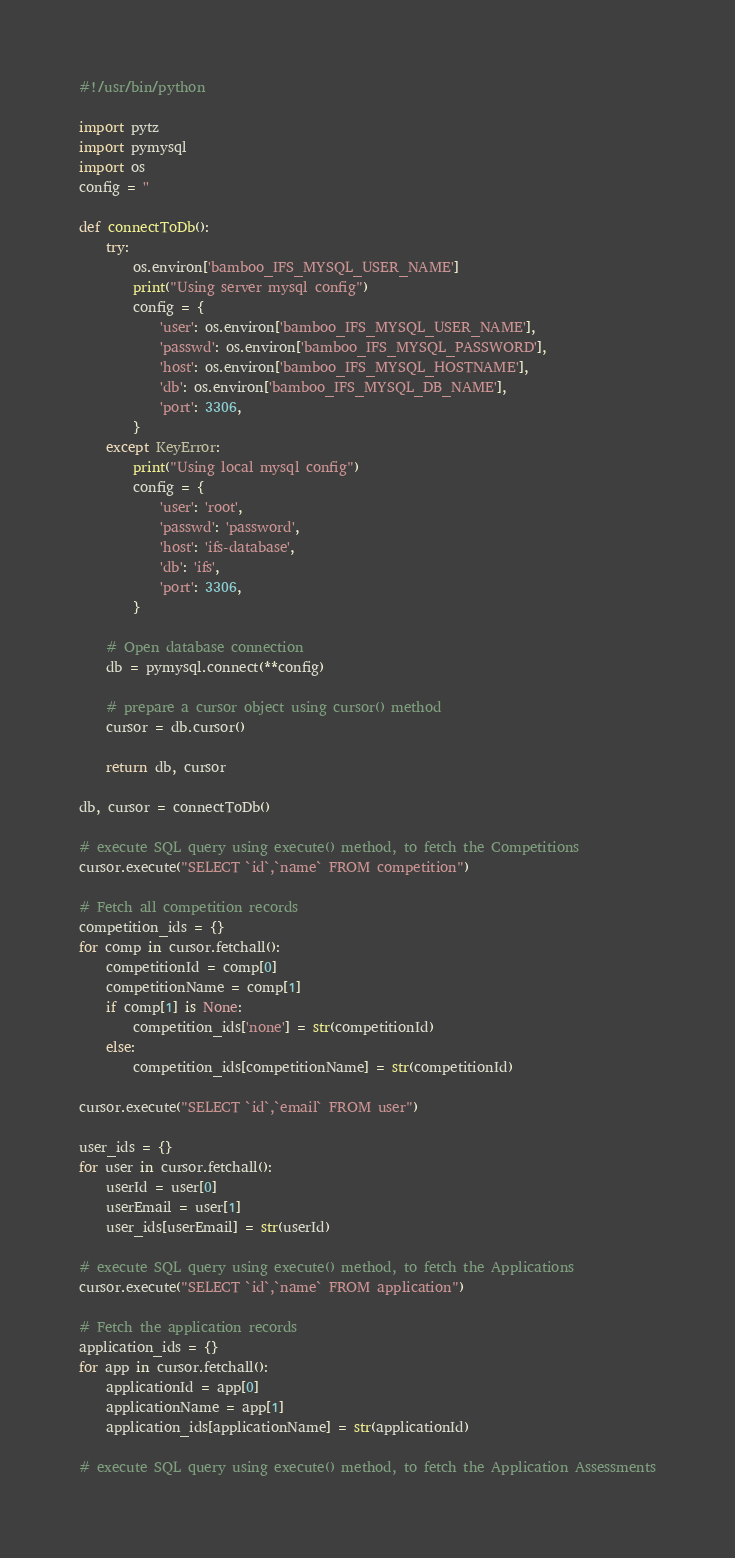<code> <loc_0><loc_0><loc_500><loc_500><_Python_>#!/usr/bin/python

import pytz
import pymysql
import os
config = ''

def connectToDb():
    try:
        os.environ['bamboo_IFS_MYSQL_USER_NAME']
        print("Using server mysql config")
        config = {
            'user': os.environ['bamboo_IFS_MYSQL_USER_NAME'],
            'passwd': os.environ['bamboo_IFS_MYSQL_PASSWORD'],
            'host': os.environ['bamboo_IFS_MYSQL_HOSTNAME'],
            'db': os.environ['bamboo_IFS_MYSQL_DB_NAME'],
            'port': 3306,
        }
    except KeyError:
        print("Using local mysql config")
        config = {
            'user': 'root',
            'passwd': 'password',
            'host': 'ifs-database',
            'db': 'ifs',
            'port': 3306,
        }

    # Open database connection
    db = pymysql.connect(**config)

    # prepare a cursor object using cursor() method
    cursor = db.cursor()

    return db, cursor

db, cursor = connectToDb()

# execute SQL query using execute() method, to fetch the Competitions
cursor.execute("SELECT `id`,`name` FROM competition")

# Fetch all competition records
competition_ids = {}
for comp in cursor.fetchall():
    competitionId = comp[0]
    competitionName = comp[1]
    if comp[1] is None:
        competition_ids['none'] = str(competitionId)
    else:
        competition_ids[competitionName] = str(competitionId)

cursor.execute("SELECT `id`,`email` FROM user")

user_ids = {}
for user in cursor.fetchall():
    userId = user[0]
    userEmail = user[1]
    user_ids[userEmail] = str(userId)

# execute SQL query using execute() method, to fetch the Applications
cursor.execute("SELECT `id`,`name` FROM application")

# Fetch the application records
application_ids = {}
for app in cursor.fetchall():
    applicationId = app[0]
    applicationName = app[1]
    application_ids[applicationName] = str(applicationId)

# execute SQL query using execute() method, to fetch the Application Assessments</code> 